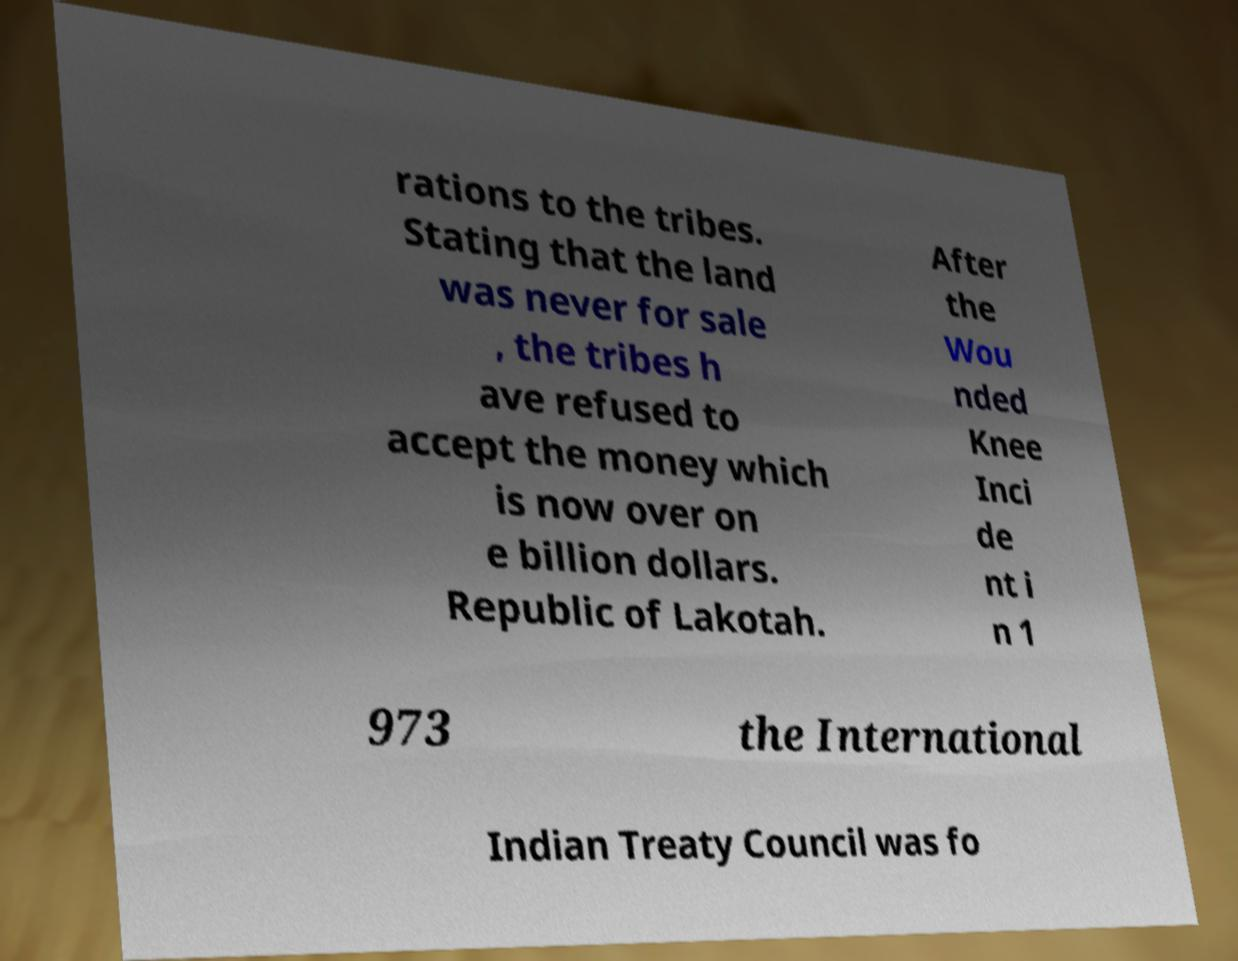I need the written content from this picture converted into text. Can you do that? rations to the tribes. Stating that the land was never for sale , the tribes h ave refused to accept the money which is now over on e billion dollars. Republic of Lakotah. After the Wou nded Knee Inci de nt i n 1 973 the International Indian Treaty Council was fo 